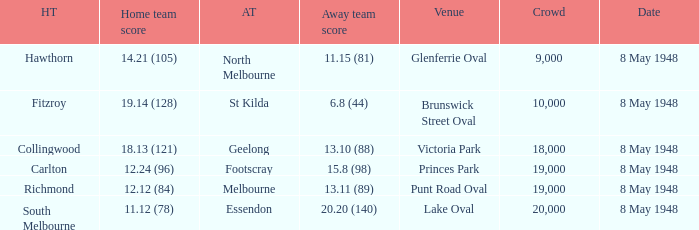Would you be able to parse every entry in this table? {'header': ['HT', 'Home team score', 'AT', 'Away team score', 'Venue', 'Crowd', 'Date'], 'rows': [['Hawthorn', '14.21 (105)', 'North Melbourne', '11.15 (81)', 'Glenferrie Oval', '9,000', '8 May 1948'], ['Fitzroy', '19.14 (128)', 'St Kilda', '6.8 (44)', 'Brunswick Street Oval', '10,000', '8 May 1948'], ['Collingwood', '18.13 (121)', 'Geelong', '13.10 (88)', 'Victoria Park', '18,000', '8 May 1948'], ['Carlton', '12.24 (96)', 'Footscray', '15.8 (98)', 'Princes Park', '19,000', '8 May 1948'], ['Richmond', '12.12 (84)', 'Melbourne', '13.11 (89)', 'Punt Road Oval', '19,000', '8 May 1948'], ['South Melbourne', '11.12 (78)', 'Essendon', '20.20 (140)', 'Lake Oval', '20,000', '8 May 1948']]} Which away team played the home team when they scored 14.21 (105)? North Melbourne. 